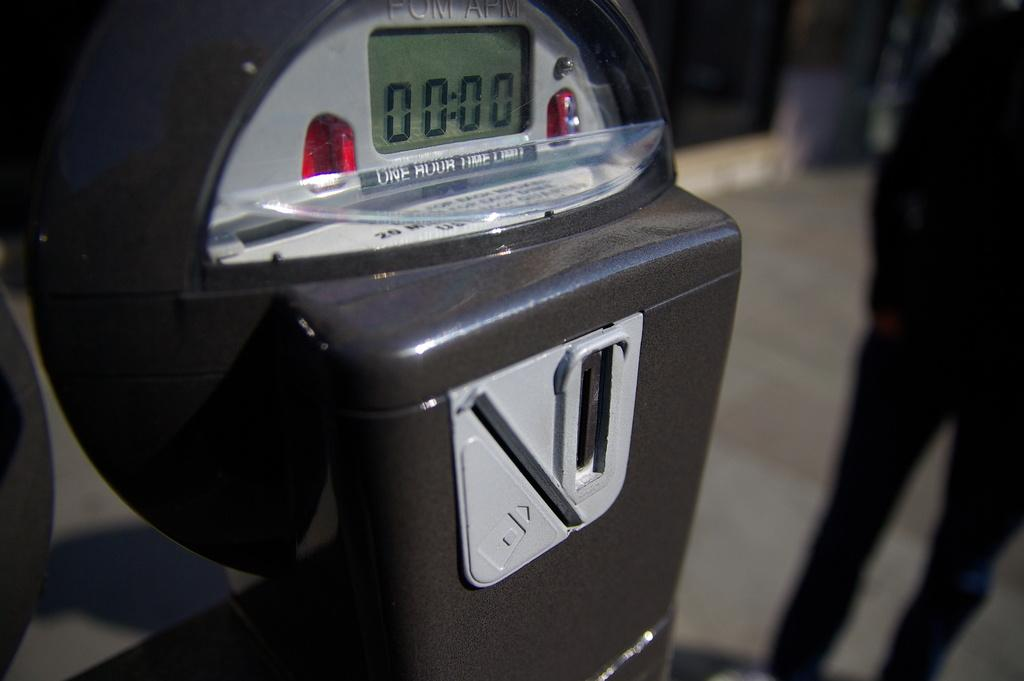<image>
Give a short and clear explanation of the subsequent image. A parking meter that claims a one hour time limit. 